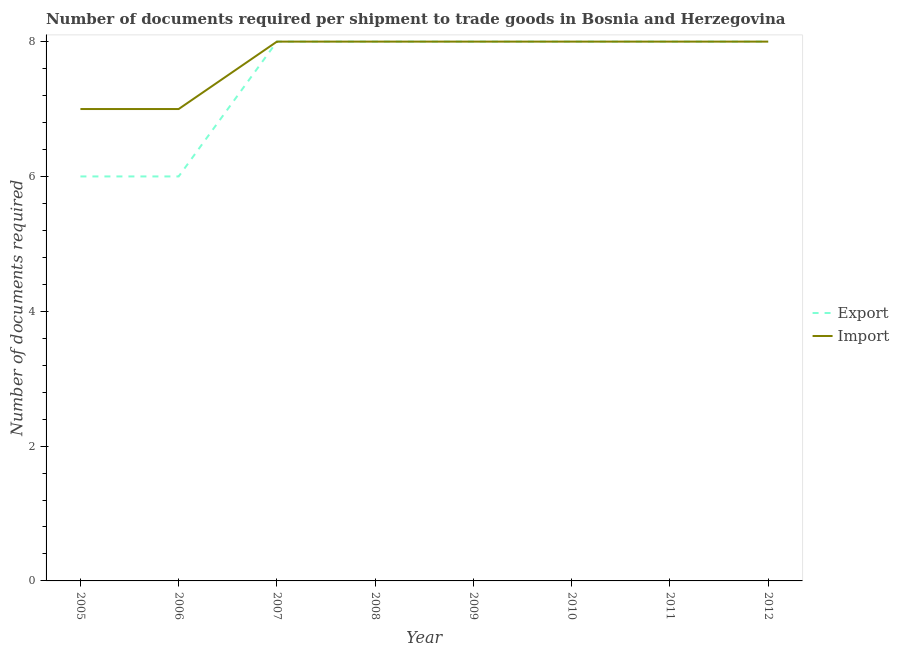How many different coloured lines are there?
Give a very brief answer. 2. Is the number of lines equal to the number of legend labels?
Offer a very short reply. Yes. What is the number of documents required to export goods in 2012?
Your answer should be very brief. 8. Across all years, what is the maximum number of documents required to import goods?
Make the answer very short. 8. Across all years, what is the minimum number of documents required to import goods?
Your answer should be very brief. 7. In which year was the number of documents required to import goods maximum?
Provide a short and direct response. 2007. In which year was the number of documents required to export goods minimum?
Your answer should be compact. 2005. What is the total number of documents required to import goods in the graph?
Offer a very short reply. 62. What is the difference between the number of documents required to import goods in 2006 and that in 2008?
Make the answer very short. -1. What is the average number of documents required to import goods per year?
Your answer should be very brief. 7.75. What is the ratio of the number of documents required to import goods in 2009 to that in 2012?
Your response must be concise. 1. Is the number of documents required to export goods in 2006 less than that in 2008?
Make the answer very short. Yes. What is the difference between the highest and the lowest number of documents required to export goods?
Your answer should be very brief. 2. Is the sum of the number of documents required to export goods in 2007 and 2008 greater than the maximum number of documents required to import goods across all years?
Your response must be concise. Yes. Does the number of documents required to export goods monotonically increase over the years?
Provide a succinct answer. No. Is the number of documents required to import goods strictly greater than the number of documents required to export goods over the years?
Ensure brevity in your answer.  No. How many lines are there?
Give a very brief answer. 2. What is the difference between two consecutive major ticks on the Y-axis?
Ensure brevity in your answer.  2. Are the values on the major ticks of Y-axis written in scientific E-notation?
Your response must be concise. No. Does the graph contain any zero values?
Your response must be concise. No. Does the graph contain grids?
Offer a very short reply. No. Where does the legend appear in the graph?
Provide a short and direct response. Center right. How are the legend labels stacked?
Make the answer very short. Vertical. What is the title of the graph?
Provide a succinct answer. Number of documents required per shipment to trade goods in Bosnia and Herzegovina. Does "UN agencies" appear as one of the legend labels in the graph?
Your answer should be very brief. No. What is the label or title of the Y-axis?
Ensure brevity in your answer.  Number of documents required. What is the Number of documents required of Import in 2005?
Ensure brevity in your answer.  7. What is the Number of documents required in Export in 2006?
Provide a short and direct response. 6. What is the Number of documents required in Import in 2007?
Give a very brief answer. 8. What is the Number of documents required in Export in 2008?
Your answer should be compact. 8. What is the Number of documents required of Import in 2010?
Ensure brevity in your answer.  8. What is the Number of documents required of Import in 2011?
Offer a terse response. 8. What is the Number of documents required in Import in 2012?
Make the answer very short. 8. Across all years, what is the maximum Number of documents required in Export?
Offer a terse response. 8. Across all years, what is the minimum Number of documents required of Export?
Provide a succinct answer. 6. What is the total Number of documents required of Import in the graph?
Offer a very short reply. 62. What is the difference between the Number of documents required in Export in 2005 and that in 2006?
Offer a very short reply. 0. What is the difference between the Number of documents required of Export in 2005 and that in 2007?
Ensure brevity in your answer.  -2. What is the difference between the Number of documents required in Export in 2005 and that in 2008?
Offer a very short reply. -2. What is the difference between the Number of documents required in Import in 2005 and that in 2008?
Keep it short and to the point. -1. What is the difference between the Number of documents required in Export in 2005 and that in 2009?
Your answer should be very brief. -2. What is the difference between the Number of documents required of Import in 2005 and that in 2010?
Keep it short and to the point. -1. What is the difference between the Number of documents required of Export in 2005 and that in 2011?
Your answer should be very brief. -2. What is the difference between the Number of documents required of Import in 2005 and that in 2011?
Your response must be concise. -1. What is the difference between the Number of documents required in Export in 2005 and that in 2012?
Offer a terse response. -2. What is the difference between the Number of documents required in Import in 2005 and that in 2012?
Ensure brevity in your answer.  -1. What is the difference between the Number of documents required of Export in 2006 and that in 2008?
Give a very brief answer. -2. What is the difference between the Number of documents required in Import in 2006 and that in 2010?
Your response must be concise. -1. What is the difference between the Number of documents required in Import in 2006 and that in 2011?
Provide a succinct answer. -1. What is the difference between the Number of documents required of Export in 2006 and that in 2012?
Make the answer very short. -2. What is the difference between the Number of documents required in Import in 2006 and that in 2012?
Your answer should be very brief. -1. What is the difference between the Number of documents required in Import in 2007 and that in 2008?
Your response must be concise. 0. What is the difference between the Number of documents required of Import in 2007 and that in 2009?
Keep it short and to the point. 0. What is the difference between the Number of documents required of Export in 2007 and that in 2010?
Provide a short and direct response. 0. What is the difference between the Number of documents required in Import in 2007 and that in 2010?
Keep it short and to the point. 0. What is the difference between the Number of documents required in Export in 2007 and that in 2011?
Offer a terse response. 0. What is the difference between the Number of documents required in Export in 2007 and that in 2012?
Provide a succinct answer. 0. What is the difference between the Number of documents required in Export in 2008 and that in 2009?
Make the answer very short. 0. What is the difference between the Number of documents required in Import in 2008 and that in 2009?
Your answer should be very brief. 0. What is the difference between the Number of documents required of Import in 2008 and that in 2010?
Your response must be concise. 0. What is the difference between the Number of documents required in Import in 2008 and that in 2011?
Your answer should be very brief. 0. What is the difference between the Number of documents required of Export in 2008 and that in 2012?
Your answer should be very brief. 0. What is the difference between the Number of documents required in Export in 2009 and that in 2012?
Provide a succinct answer. 0. What is the difference between the Number of documents required of Import in 2009 and that in 2012?
Your answer should be compact. 0. What is the difference between the Number of documents required in Export in 2010 and that in 2011?
Offer a terse response. 0. What is the difference between the Number of documents required of Export in 2010 and that in 2012?
Provide a short and direct response. 0. What is the difference between the Number of documents required in Export in 2011 and that in 2012?
Your answer should be very brief. 0. What is the difference between the Number of documents required of Export in 2005 and the Number of documents required of Import in 2006?
Provide a short and direct response. -1. What is the difference between the Number of documents required of Export in 2005 and the Number of documents required of Import in 2007?
Offer a very short reply. -2. What is the difference between the Number of documents required of Export in 2005 and the Number of documents required of Import in 2008?
Your answer should be compact. -2. What is the difference between the Number of documents required in Export in 2005 and the Number of documents required in Import in 2009?
Offer a terse response. -2. What is the difference between the Number of documents required in Export in 2005 and the Number of documents required in Import in 2011?
Ensure brevity in your answer.  -2. What is the difference between the Number of documents required of Export in 2005 and the Number of documents required of Import in 2012?
Your answer should be very brief. -2. What is the difference between the Number of documents required in Export in 2006 and the Number of documents required in Import in 2009?
Offer a very short reply. -2. What is the difference between the Number of documents required in Export in 2007 and the Number of documents required in Import in 2008?
Offer a very short reply. 0. What is the difference between the Number of documents required of Export in 2007 and the Number of documents required of Import in 2009?
Ensure brevity in your answer.  0. What is the difference between the Number of documents required in Export in 2007 and the Number of documents required in Import in 2010?
Keep it short and to the point. 0. What is the difference between the Number of documents required in Export in 2007 and the Number of documents required in Import in 2011?
Your response must be concise. 0. What is the difference between the Number of documents required of Export in 2008 and the Number of documents required of Import in 2010?
Ensure brevity in your answer.  0. What is the difference between the Number of documents required of Export in 2008 and the Number of documents required of Import in 2011?
Keep it short and to the point. 0. What is the difference between the Number of documents required in Export in 2008 and the Number of documents required in Import in 2012?
Provide a short and direct response. 0. What is the difference between the Number of documents required in Export in 2009 and the Number of documents required in Import in 2012?
Provide a succinct answer. 0. What is the difference between the Number of documents required in Export in 2010 and the Number of documents required in Import in 2012?
Provide a short and direct response. 0. What is the average Number of documents required in Export per year?
Your response must be concise. 7.5. What is the average Number of documents required in Import per year?
Make the answer very short. 7.75. In the year 2010, what is the difference between the Number of documents required in Export and Number of documents required in Import?
Your answer should be very brief. 0. What is the ratio of the Number of documents required of Export in 2005 to that in 2006?
Your answer should be compact. 1. What is the ratio of the Number of documents required of Export in 2005 to that in 2008?
Provide a succinct answer. 0.75. What is the ratio of the Number of documents required in Export in 2005 to that in 2011?
Ensure brevity in your answer.  0.75. What is the ratio of the Number of documents required in Import in 2005 to that in 2011?
Your answer should be very brief. 0.88. What is the ratio of the Number of documents required in Export in 2006 to that in 2007?
Your answer should be compact. 0.75. What is the ratio of the Number of documents required in Import in 2006 to that in 2007?
Make the answer very short. 0.88. What is the ratio of the Number of documents required of Export in 2006 to that in 2012?
Your answer should be compact. 0.75. What is the ratio of the Number of documents required in Export in 2007 to that in 2011?
Provide a succinct answer. 1. What is the ratio of the Number of documents required in Export in 2007 to that in 2012?
Keep it short and to the point. 1. What is the ratio of the Number of documents required in Export in 2008 to that in 2009?
Your answer should be compact. 1. What is the ratio of the Number of documents required of Import in 2008 to that in 2009?
Your answer should be very brief. 1. What is the ratio of the Number of documents required of Import in 2008 to that in 2012?
Offer a terse response. 1. What is the ratio of the Number of documents required of Export in 2009 to that in 2010?
Ensure brevity in your answer.  1. What is the ratio of the Number of documents required of Import in 2009 to that in 2010?
Your answer should be compact. 1. What is the ratio of the Number of documents required of Export in 2009 to that in 2011?
Provide a succinct answer. 1. What is the ratio of the Number of documents required of Export in 2009 to that in 2012?
Ensure brevity in your answer.  1. What is the ratio of the Number of documents required of Import in 2009 to that in 2012?
Make the answer very short. 1. What is the ratio of the Number of documents required of Import in 2010 to that in 2011?
Give a very brief answer. 1. What is the ratio of the Number of documents required of Export in 2010 to that in 2012?
Your answer should be very brief. 1. What is the ratio of the Number of documents required in Export in 2011 to that in 2012?
Ensure brevity in your answer.  1. What is the difference between the highest and the lowest Number of documents required in Import?
Ensure brevity in your answer.  1. 